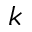<formula> <loc_0><loc_0><loc_500><loc_500>k</formula> 